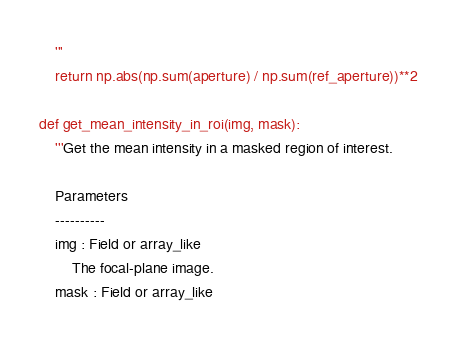<code> <loc_0><loc_0><loc_500><loc_500><_Python_>	'''
	return np.abs(np.sum(aperture) / np.sum(ref_aperture))**2

def get_mean_intensity_in_roi(img, mask):
	'''Get the mean intensity in a masked region of interest.

	Parameters
	----------
	img : Field or array_like
		The focal-plane image.
	mask : Field or array_like</code> 